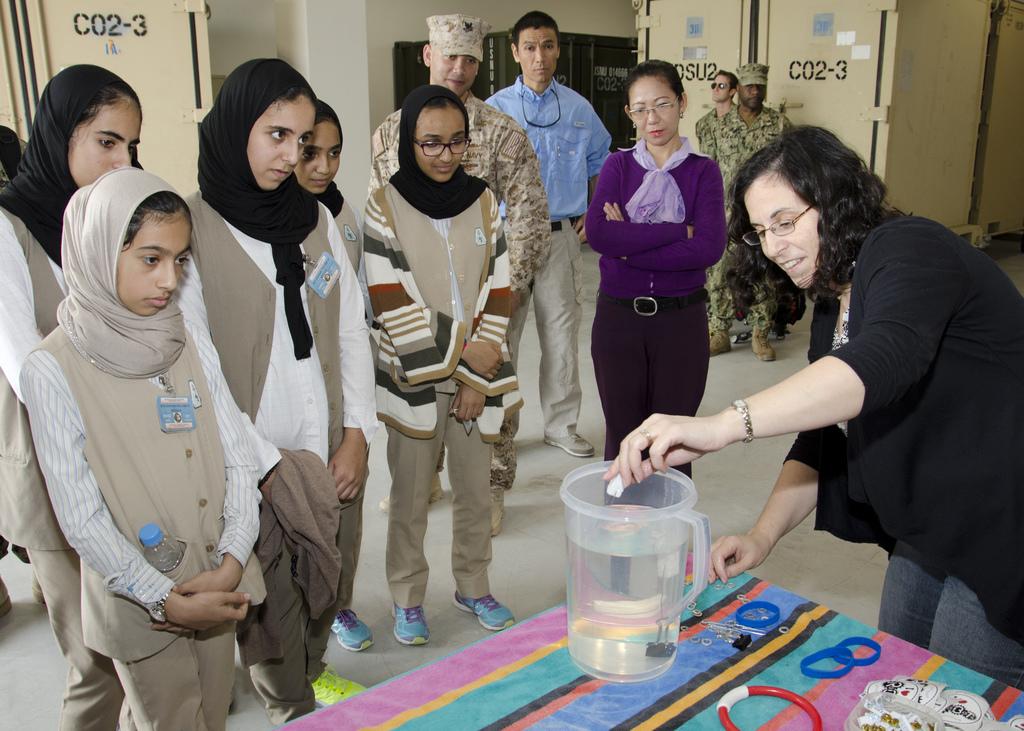What is the code on the locker/cupboard to the left of the image?
Provide a succinct answer. C02-3. 